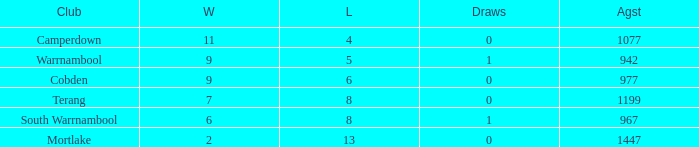What's the number of losses when the wins were more than 11 and had 0 draws? 0.0. 